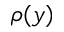<formula> <loc_0><loc_0><loc_500><loc_500>\rho ( y )</formula> 